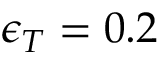Convert formula to latex. <formula><loc_0><loc_0><loc_500><loc_500>\epsilon _ { T } = 0 . 2 \</formula> 